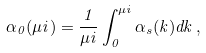<formula> <loc_0><loc_0><loc_500><loc_500>\alpha _ { 0 } ( \mu i ) = \frac { 1 } { \mu i } \int _ { 0 } ^ { \mu i } \alpha _ { s } ( k ) d k \, ,</formula> 